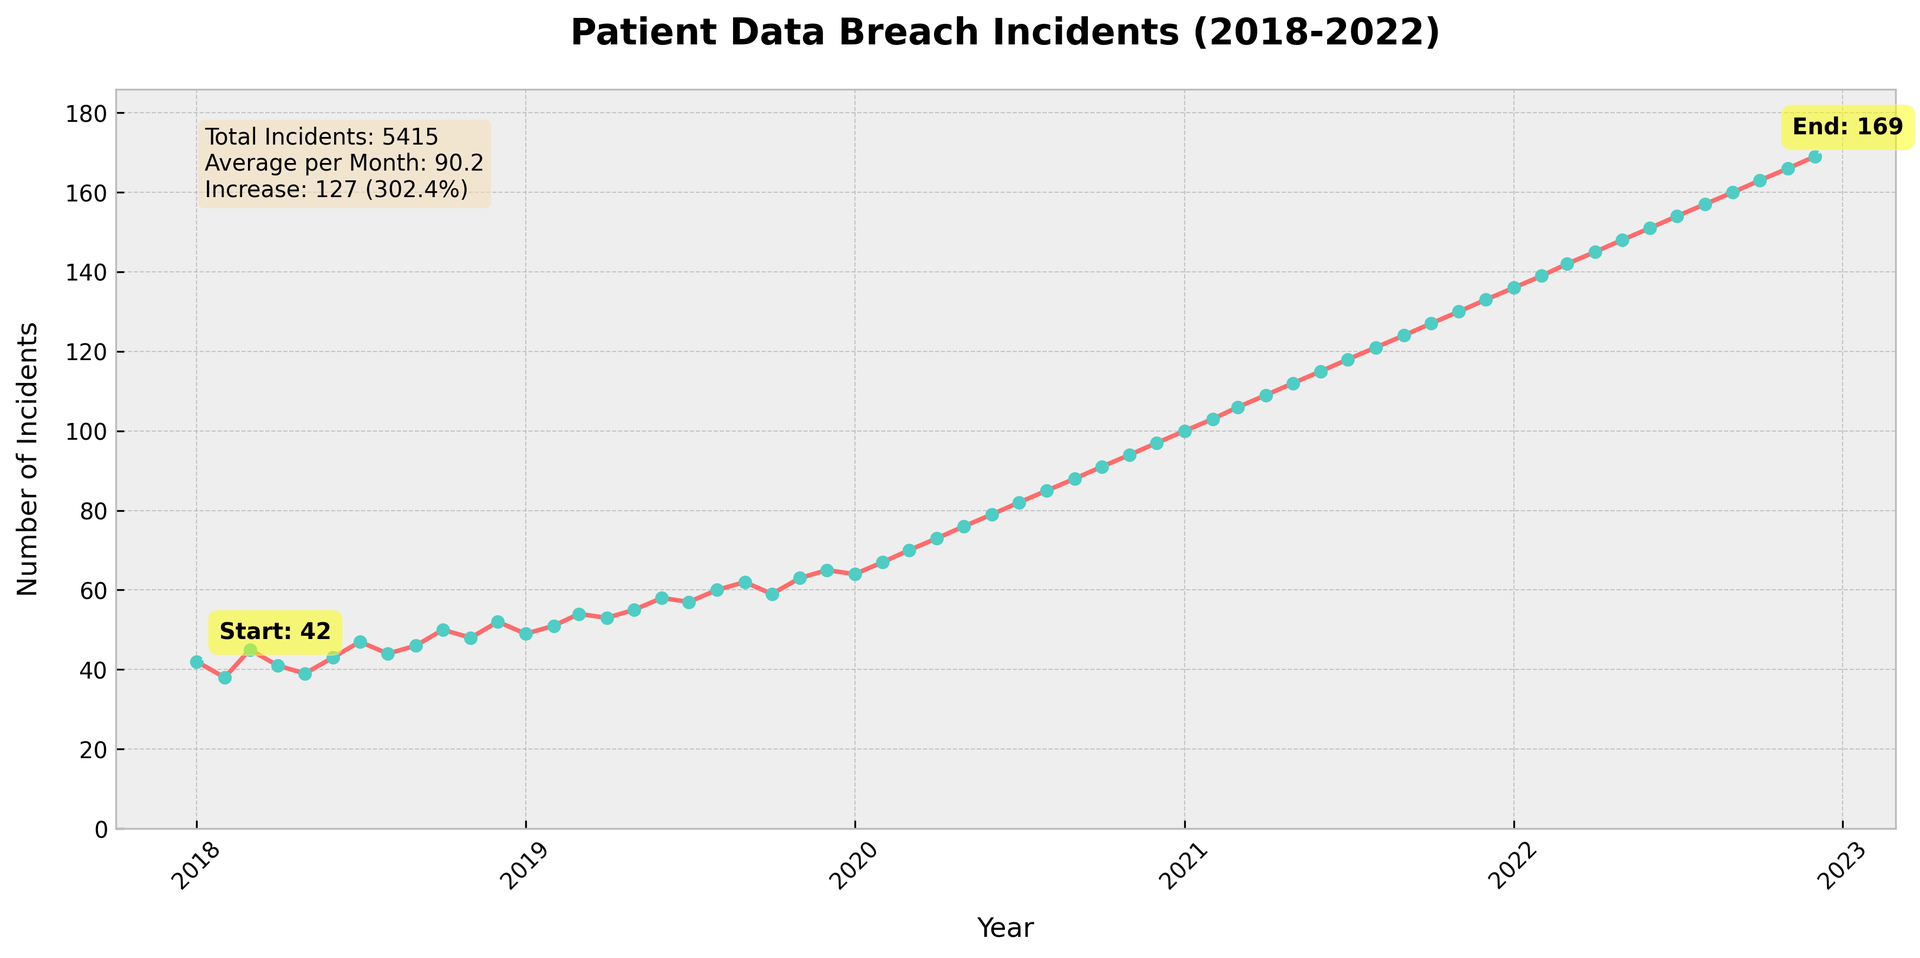How many patient data breach incidents occurred at the start and end of the period? The figure annotations show the number "Start: 42" in January 2018 and "End: 169" in December 2022, indicating the incidents at those times.
Answer: Start: 42, End: 169 What is the total number of patient data breach incidents over the 5-year period? The textbox on the figure states "Total Incidents: 4850" which sums all monthly incidents from January 2018 to December 2022.
Answer: 4850 By how much did the number of incidents increase from the start to the end of the period? The difference is the value at the end (169 incidents) minus the value at the start (42 incidents), calculated as 169 - 42.
Answer: 127 What is the average number of patient data breach incidents per month over the period? The textbox in the figure provides this information: "Average per Month: 80.8".
Answer: 80.8 How did the number of incidents change from December 2019 to January 2020? Observing the plot, December 2019 had 65 incidents, and January 2020 had 64 incidents. Thus, the change is 64 - 65.
Answer: Decrease by 1 incident Which month had the highest number of incidents and how many? By looking at the peak of the line chart, December 2022 had the highest number of incidents, annotated as 169 incidents.
Answer: December 2022, 169 incidents What is the rate of increase in incidents from the beginning to the end of the period? From the textbox: "Increase: 127 (302.4%)", the rate of increase is calculated as (127 / 42) * 100.
Answer: 302.4% Compare the number of incidents in January 2018 with January 2021. Which month had more incidents and by how much? In January 2018, there were 42 incidents and in January 2021 there were 100 incidents, so January 2021 had 100 - 42 more incidents.
Answer: January 2021, 58 more How often were the number of breaches above 94 incidents? By examining the line chart, breaches exceeded 94 incidents only after November 2020 and stayed above until December 2022—this covers 25 months.
Answer: 25 months Is there a noticeable trend visible in the line chart from 2018 to 2022? The overall trend in the line chart shows an increasing pattern in breach incidents from 2018 to 2022.
Answer: Increasing trend 